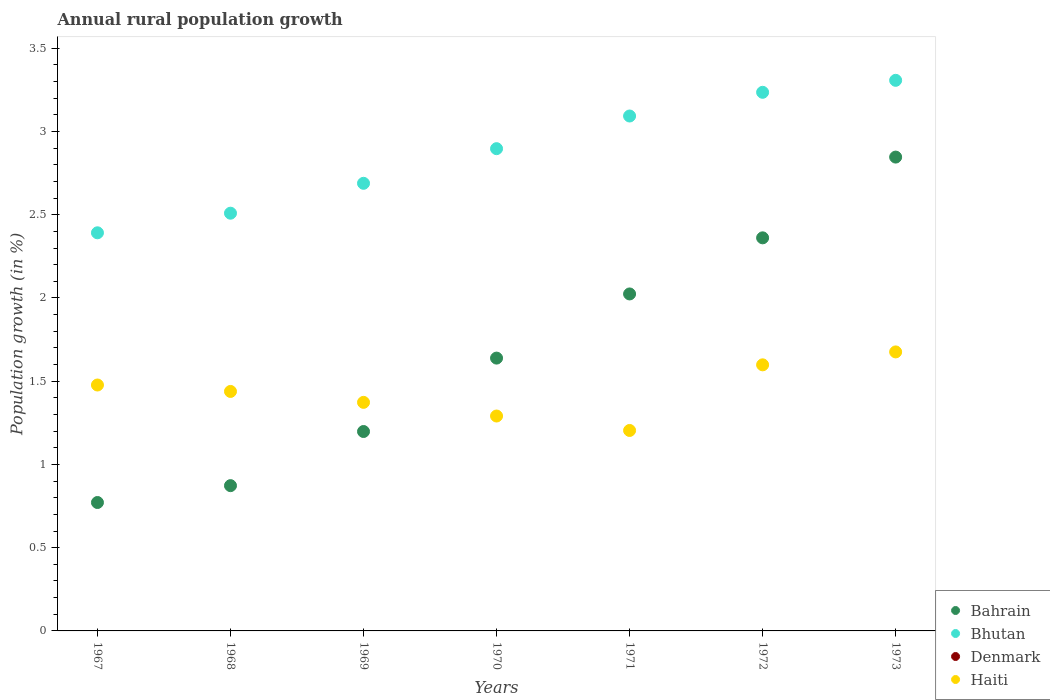How many different coloured dotlines are there?
Ensure brevity in your answer.  3. What is the percentage of rural population growth in Haiti in 1971?
Provide a succinct answer. 1.2. Across all years, what is the maximum percentage of rural population growth in Bhutan?
Your answer should be very brief. 3.31. Across all years, what is the minimum percentage of rural population growth in Denmark?
Provide a short and direct response. 0. In which year was the percentage of rural population growth in Bahrain maximum?
Offer a very short reply. 1973. What is the total percentage of rural population growth in Denmark in the graph?
Ensure brevity in your answer.  0. What is the difference between the percentage of rural population growth in Bhutan in 1969 and that in 1972?
Ensure brevity in your answer.  -0.55. What is the difference between the percentage of rural population growth in Bhutan in 1967 and the percentage of rural population growth in Bahrain in 1970?
Your response must be concise. 0.75. What is the average percentage of rural population growth in Bhutan per year?
Offer a very short reply. 2.87. In the year 1970, what is the difference between the percentage of rural population growth in Bahrain and percentage of rural population growth in Haiti?
Offer a terse response. 0.35. What is the ratio of the percentage of rural population growth in Haiti in 1970 to that in 1971?
Ensure brevity in your answer.  1.07. Is the percentage of rural population growth in Bahrain in 1969 less than that in 1970?
Offer a very short reply. Yes. Is the difference between the percentage of rural population growth in Bahrain in 1967 and 1973 greater than the difference between the percentage of rural population growth in Haiti in 1967 and 1973?
Keep it short and to the point. No. What is the difference between the highest and the second highest percentage of rural population growth in Bhutan?
Your response must be concise. 0.07. What is the difference between the highest and the lowest percentage of rural population growth in Haiti?
Keep it short and to the point. 0.47. In how many years, is the percentage of rural population growth in Denmark greater than the average percentage of rural population growth in Denmark taken over all years?
Provide a succinct answer. 0. Is it the case that in every year, the sum of the percentage of rural population growth in Denmark and percentage of rural population growth in Haiti  is greater than the percentage of rural population growth in Bhutan?
Offer a terse response. No. Is the percentage of rural population growth in Bhutan strictly greater than the percentage of rural population growth in Haiti over the years?
Your answer should be very brief. Yes. How many years are there in the graph?
Offer a very short reply. 7. What is the difference between two consecutive major ticks on the Y-axis?
Give a very brief answer. 0.5. Are the values on the major ticks of Y-axis written in scientific E-notation?
Offer a terse response. No. Where does the legend appear in the graph?
Provide a succinct answer. Bottom right. How many legend labels are there?
Ensure brevity in your answer.  4. What is the title of the graph?
Offer a terse response. Annual rural population growth. Does "Nepal" appear as one of the legend labels in the graph?
Ensure brevity in your answer.  No. What is the label or title of the X-axis?
Provide a short and direct response. Years. What is the label or title of the Y-axis?
Keep it short and to the point. Population growth (in %). What is the Population growth (in %) of Bahrain in 1967?
Provide a short and direct response. 0.77. What is the Population growth (in %) in Bhutan in 1967?
Offer a terse response. 2.39. What is the Population growth (in %) in Haiti in 1967?
Provide a succinct answer. 1.48. What is the Population growth (in %) in Bahrain in 1968?
Your answer should be very brief. 0.87. What is the Population growth (in %) of Bhutan in 1968?
Give a very brief answer. 2.51. What is the Population growth (in %) in Denmark in 1968?
Provide a succinct answer. 0. What is the Population growth (in %) of Haiti in 1968?
Offer a very short reply. 1.44. What is the Population growth (in %) in Bahrain in 1969?
Ensure brevity in your answer.  1.2. What is the Population growth (in %) of Bhutan in 1969?
Provide a short and direct response. 2.69. What is the Population growth (in %) in Denmark in 1969?
Provide a succinct answer. 0. What is the Population growth (in %) in Haiti in 1969?
Provide a succinct answer. 1.37. What is the Population growth (in %) of Bahrain in 1970?
Your answer should be compact. 1.64. What is the Population growth (in %) in Bhutan in 1970?
Give a very brief answer. 2.9. What is the Population growth (in %) of Haiti in 1970?
Your answer should be very brief. 1.29. What is the Population growth (in %) in Bahrain in 1971?
Make the answer very short. 2.02. What is the Population growth (in %) of Bhutan in 1971?
Keep it short and to the point. 3.09. What is the Population growth (in %) in Denmark in 1971?
Your response must be concise. 0. What is the Population growth (in %) of Haiti in 1971?
Your response must be concise. 1.2. What is the Population growth (in %) in Bahrain in 1972?
Offer a terse response. 2.36. What is the Population growth (in %) of Bhutan in 1972?
Your answer should be compact. 3.24. What is the Population growth (in %) in Haiti in 1972?
Your answer should be very brief. 1.6. What is the Population growth (in %) of Bahrain in 1973?
Make the answer very short. 2.85. What is the Population growth (in %) of Bhutan in 1973?
Ensure brevity in your answer.  3.31. What is the Population growth (in %) of Denmark in 1973?
Ensure brevity in your answer.  0. What is the Population growth (in %) of Haiti in 1973?
Keep it short and to the point. 1.68. Across all years, what is the maximum Population growth (in %) of Bahrain?
Your response must be concise. 2.85. Across all years, what is the maximum Population growth (in %) in Bhutan?
Keep it short and to the point. 3.31. Across all years, what is the maximum Population growth (in %) of Haiti?
Make the answer very short. 1.68. Across all years, what is the minimum Population growth (in %) in Bahrain?
Your answer should be very brief. 0.77. Across all years, what is the minimum Population growth (in %) in Bhutan?
Offer a terse response. 2.39. Across all years, what is the minimum Population growth (in %) of Haiti?
Offer a terse response. 1.2. What is the total Population growth (in %) in Bahrain in the graph?
Give a very brief answer. 11.71. What is the total Population growth (in %) in Bhutan in the graph?
Your answer should be compact. 20.12. What is the total Population growth (in %) of Haiti in the graph?
Provide a succinct answer. 10.06. What is the difference between the Population growth (in %) in Bahrain in 1967 and that in 1968?
Your response must be concise. -0.1. What is the difference between the Population growth (in %) in Bhutan in 1967 and that in 1968?
Your response must be concise. -0.12. What is the difference between the Population growth (in %) in Haiti in 1967 and that in 1968?
Provide a succinct answer. 0.04. What is the difference between the Population growth (in %) of Bahrain in 1967 and that in 1969?
Offer a terse response. -0.43. What is the difference between the Population growth (in %) of Bhutan in 1967 and that in 1969?
Keep it short and to the point. -0.3. What is the difference between the Population growth (in %) in Haiti in 1967 and that in 1969?
Ensure brevity in your answer.  0.1. What is the difference between the Population growth (in %) in Bahrain in 1967 and that in 1970?
Your answer should be very brief. -0.87. What is the difference between the Population growth (in %) of Bhutan in 1967 and that in 1970?
Ensure brevity in your answer.  -0.51. What is the difference between the Population growth (in %) in Haiti in 1967 and that in 1970?
Keep it short and to the point. 0.19. What is the difference between the Population growth (in %) of Bahrain in 1967 and that in 1971?
Make the answer very short. -1.25. What is the difference between the Population growth (in %) in Bhutan in 1967 and that in 1971?
Give a very brief answer. -0.7. What is the difference between the Population growth (in %) in Haiti in 1967 and that in 1971?
Keep it short and to the point. 0.27. What is the difference between the Population growth (in %) of Bahrain in 1967 and that in 1972?
Provide a short and direct response. -1.59. What is the difference between the Population growth (in %) of Bhutan in 1967 and that in 1972?
Provide a succinct answer. -0.84. What is the difference between the Population growth (in %) in Haiti in 1967 and that in 1972?
Keep it short and to the point. -0.12. What is the difference between the Population growth (in %) of Bahrain in 1967 and that in 1973?
Give a very brief answer. -2.07. What is the difference between the Population growth (in %) in Bhutan in 1967 and that in 1973?
Make the answer very short. -0.92. What is the difference between the Population growth (in %) in Haiti in 1967 and that in 1973?
Provide a short and direct response. -0.2. What is the difference between the Population growth (in %) in Bahrain in 1968 and that in 1969?
Provide a succinct answer. -0.33. What is the difference between the Population growth (in %) of Bhutan in 1968 and that in 1969?
Offer a terse response. -0.18. What is the difference between the Population growth (in %) of Haiti in 1968 and that in 1969?
Make the answer very short. 0.07. What is the difference between the Population growth (in %) in Bahrain in 1968 and that in 1970?
Provide a short and direct response. -0.77. What is the difference between the Population growth (in %) of Bhutan in 1968 and that in 1970?
Your response must be concise. -0.39. What is the difference between the Population growth (in %) in Haiti in 1968 and that in 1970?
Make the answer very short. 0.15. What is the difference between the Population growth (in %) of Bahrain in 1968 and that in 1971?
Offer a very short reply. -1.15. What is the difference between the Population growth (in %) in Bhutan in 1968 and that in 1971?
Your response must be concise. -0.58. What is the difference between the Population growth (in %) in Haiti in 1968 and that in 1971?
Provide a succinct answer. 0.23. What is the difference between the Population growth (in %) of Bahrain in 1968 and that in 1972?
Offer a terse response. -1.49. What is the difference between the Population growth (in %) in Bhutan in 1968 and that in 1972?
Your response must be concise. -0.73. What is the difference between the Population growth (in %) in Haiti in 1968 and that in 1972?
Provide a succinct answer. -0.16. What is the difference between the Population growth (in %) of Bahrain in 1968 and that in 1973?
Keep it short and to the point. -1.97. What is the difference between the Population growth (in %) of Bhutan in 1968 and that in 1973?
Your response must be concise. -0.8. What is the difference between the Population growth (in %) in Haiti in 1968 and that in 1973?
Make the answer very short. -0.24. What is the difference between the Population growth (in %) in Bahrain in 1969 and that in 1970?
Your response must be concise. -0.44. What is the difference between the Population growth (in %) of Bhutan in 1969 and that in 1970?
Your response must be concise. -0.21. What is the difference between the Population growth (in %) in Haiti in 1969 and that in 1970?
Give a very brief answer. 0.08. What is the difference between the Population growth (in %) of Bahrain in 1969 and that in 1971?
Keep it short and to the point. -0.83. What is the difference between the Population growth (in %) in Bhutan in 1969 and that in 1971?
Make the answer very short. -0.4. What is the difference between the Population growth (in %) of Haiti in 1969 and that in 1971?
Make the answer very short. 0.17. What is the difference between the Population growth (in %) of Bahrain in 1969 and that in 1972?
Ensure brevity in your answer.  -1.16. What is the difference between the Population growth (in %) of Bhutan in 1969 and that in 1972?
Give a very brief answer. -0.55. What is the difference between the Population growth (in %) of Haiti in 1969 and that in 1972?
Your answer should be compact. -0.23. What is the difference between the Population growth (in %) in Bahrain in 1969 and that in 1973?
Offer a very short reply. -1.65. What is the difference between the Population growth (in %) in Bhutan in 1969 and that in 1973?
Ensure brevity in your answer.  -0.62. What is the difference between the Population growth (in %) of Haiti in 1969 and that in 1973?
Ensure brevity in your answer.  -0.3. What is the difference between the Population growth (in %) in Bahrain in 1970 and that in 1971?
Provide a succinct answer. -0.39. What is the difference between the Population growth (in %) of Bhutan in 1970 and that in 1971?
Your answer should be very brief. -0.2. What is the difference between the Population growth (in %) of Haiti in 1970 and that in 1971?
Offer a very short reply. 0.09. What is the difference between the Population growth (in %) in Bahrain in 1970 and that in 1972?
Your answer should be very brief. -0.72. What is the difference between the Population growth (in %) of Bhutan in 1970 and that in 1972?
Keep it short and to the point. -0.34. What is the difference between the Population growth (in %) of Haiti in 1970 and that in 1972?
Make the answer very short. -0.31. What is the difference between the Population growth (in %) in Bahrain in 1970 and that in 1973?
Give a very brief answer. -1.21. What is the difference between the Population growth (in %) of Bhutan in 1970 and that in 1973?
Your response must be concise. -0.41. What is the difference between the Population growth (in %) in Haiti in 1970 and that in 1973?
Offer a terse response. -0.39. What is the difference between the Population growth (in %) of Bahrain in 1971 and that in 1972?
Offer a very short reply. -0.34. What is the difference between the Population growth (in %) of Bhutan in 1971 and that in 1972?
Make the answer very short. -0.14. What is the difference between the Population growth (in %) in Haiti in 1971 and that in 1972?
Keep it short and to the point. -0.39. What is the difference between the Population growth (in %) in Bahrain in 1971 and that in 1973?
Provide a short and direct response. -0.82. What is the difference between the Population growth (in %) of Bhutan in 1971 and that in 1973?
Your answer should be compact. -0.21. What is the difference between the Population growth (in %) of Haiti in 1971 and that in 1973?
Provide a succinct answer. -0.47. What is the difference between the Population growth (in %) of Bahrain in 1972 and that in 1973?
Ensure brevity in your answer.  -0.49. What is the difference between the Population growth (in %) in Bhutan in 1972 and that in 1973?
Provide a succinct answer. -0.07. What is the difference between the Population growth (in %) in Haiti in 1972 and that in 1973?
Your answer should be very brief. -0.08. What is the difference between the Population growth (in %) of Bahrain in 1967 and the Population growth (in %) of Bhutan in 1968?
Provide a short and direct response. -1.74. What is the difference between the Population growth (in %) in Bahrain in 1967 and the Population growth (in %) in Haiti in 1968?
Ensure brevity in your answer.  -0.67. What is the difference between the Population growth (in %) of Bhutan in 1967 and the Population growth (in %) of Haiti in 1968?
Your response must be concise. 0.95. What is the difference between the Population growth (in %) in Bahrain in 1967 and the Population growth (in %) in Bhutan in 1969?
Provide a short and direct response. -1.92. What is the difference between the Population growth (in %) in Bahrain in 1967 and the Population growth (in %) in Haiti in 1969?
Ensure brevity in your answer.  -0.6. What is the difference between the Population growth (in %) in Bhutan in 1967 and the Population growth (in %) in Haiti in 1969?
Ensure brevity in your answer.  1.02. What is the difference between the Population growth (in %) of Bahrain in 1967 and the Population growth (in %) of Bhutan in 1970?
Provide a succinct answer. -2.13. What is the difference between the Population growth (in %) in Bahrain in 1967 and the Population growth (in %) in Haiti in 1970?
Ensure brevity in your answer.  -0.52. What is the difference between the Population growth (in %) of Bhutan in 1967 and the Population growth (in %) of Haiti in 1970?
Ensure brevity in your answer.  1.1. What is the difference between the Population growth (in %) of Bahrain in 1967 and the Population growth (in %) of Bhutan in 1971?
Your response must be concise. -2.32. What is the difference between the Population growth (in %) of Bahrain in 1967 and the Population growth (in %) of Haiti in 1971?
Provide a short and direct response. -0.43. What is the difference between the Population growth (in %) in Bhutan in 1967 and the Population growth (in %) in Haiti in 1971?
Keep it short and to the point. 1.19. What is the difference between the Population growth (in %) of Bahrain in 1967 and the Population growth (in %) of Bhutan in 1972?
Your answer should be compact. -2.46. What is the difference between the Population growth (in %) in Bahrain in 1967 and the Population growth (in %) in Haiti in 1972?
Keep it short and to the point. -0.83. What is the difference between the Population growth (in %) in Bhutan in 1967 and the Population growth (in %) in Haiti in 1972?
Make the answer very short. 0.79. What is the difference between the Population growth (in %) of Bahrain in 1967 and the Population growth (in %) of Bhutan in 1973?
Give a very brief answer. -2.54. What is the difference between the Population growth (in %) of Bahrain in 1967 and the Population growth (in %) of Haiti in 1973?
Your response must be concise. -0.9. What is the difference between the Population growth (in %) in Bhutan in 1967 and the Population growth (in %) in Haiti in 1973?
Provide a succinct answer. 0.72. What is the difference between the Population growth (in %) in Bahrain in 1968 and the Population growth (in %) in Bhutan in 1969?
Your answer should be very brief. -1.82. What is the difference between the Population growth (in %) of Bahrain in 1968 and the Population growth (in %) of Haiti in 1969?
Your answer should be very brief. -0.5. What is the difference between the Population growth (in %) in Bhutan in 1968 and the Population growth (in %) in Haiti in 1969?
Make the answer very short. 1.14. What is the difference between the Population growth (in %) in Bahrain in 1968 and the Population growth (in %) in Bhutan in 1970?
Offer a very short reply. -2.02. What is the difference between the Population growth (in %) in Bahrain in 1968 and the Population growth (in %) in Haiti in 1970?
Your response must be concise. -0.42. What is the difference between the Population growth (in %) of Bhutan in 1968 and the Population growth (in %) of Haiti in 1970?
Offer a very short reply. 1.22. What is the difference between the Population growth (in %) of Bahrain in 1968 and the Population growth (in %) of Bhutan in 1971?
Keep it short and to the point. -2.22. What is the difference between the Population growth (in %) of Bahrain in 1968 and the Population growth (in %) of Haiti in 1971?
Your response must be concise. -0.33. What is the difference between the Population growth (in %) of Bhutan in 1968 and the Population growth (in %) of Haiti in 1971?
Make the answer very short. 1.31. What is the difference between the Population growth (in %) in Bahrain in 1968 and the Population growth (in %) in Bhutan in 1972?
Your response must be concise. -2.36. What is the difference between the Population growth (in %) in Bahrain in 1968 and the Population growth (in %) in Haiti in 1972?
Give a very brief answer. -0.73. What is the difference between the Population growth (in %) of Bhutan in 1968 and the Population growth (in %) of Haiti in 1972?
Offer a very short reply. 0.91. What is the difference between the Population growth (in %) in Bahrain in 1968 and the Population growth (in %) in Bhutan in 1973?
Offer a very short reply. -2.43. What is the difference between the Population growth (in %) in Bahrain in 1968 and the Population growth (in %) in Haiti in 1973?
Provide a succinct answer. -0.8. What is the difference between the Population growth (in %) of Bhutan in 1968 and the Population growth (in %) of Haiti in 1973?
Make the answer very short. 0.83. What is the difference between the Population growth (in %) in Bahrain in 1969 and the Population growth (in %) in Bhutan in 1970?
Offer a terse response. -1.7. What is the difference between the Population growth (in %) of Bahrain in 1969 and the Population growth (in %) of Haiti in 1970?
Ensure brevity in your answer.  -0.09. What is the difference between the Population growth (in %) of Bhutan in 1969 and the Population growth (in %) of Haiti in 1970?
Your answer should be compact. 1.4. What is the difference between the Population growth (in %) in Bahrain in 1969 and the Population growth (in %) in Bhutan in 1971?
Your answer should be compact. -1.9. What is the difference between the Population growth (in %) in Bahrain in 1969 and the Population growth (in %) in Haiti in 1971?
Provide a short and direct response. -0.01. What is the difference between the Population growth (in %) in Bhutan in 1969 and the Population growth (in %) in Haiti in 1971?
Offer a very short reply. 1.48. What is the difference between the Population growth (in %) of Bahrain in 1969 and the Population growth (in %) of Bhutan in 1972?
Your answer should be very brief. -2.04. What is the difference between the Population growth (in %) in Bahrain in 1969 and the Population growth (in %) in Haiti in 1972?
Your response must be concise. -0.4. What is the difference between the Population growth (in %) in Bhutan in 1969 and the Population growth (in %) in Haiti in 1972?
Offer a terse response. 1.09. What is the difference between the Population growth (in %) of Bahrain in 1969 and the Population growth (in %) of Bhutan in 1973?
Your answer should be very brief. -2.11. What is the difference between the Population growth (in %) in Bahrain in 1969 and the Population growth (in %) in Haiti in 1973?
Your response must be concise. -0.48. What is the difference between the Population growth (in %) of Bhutan in 1969 and the Population growth (in %) of Haiti in 1973?
Your response must be concise. 1.01. What is the difference between the Population growth (in %) in Bahrain in 1970 and the Population growth (in %) in Bhutan in 1971?
Offer a terse response. -1.45. What is the difference between the Population growth (in %) of Bahrain in 1970 and the Population growth (in %) of Haiti in 1971?
Ensure brevity in your answer.  0.43. What is the difference between the Population growth (in %) in Bhutan in 1970 and the Population growth (in %) in Haiti in 1971?
Provide a succinct answer. 1.69. What is the difference between the Population growth (in %) in Bahrain in 1970 and the Population growth (in %) in Bhutan in 1972?
Ensure brevity in your answer.  -1.6. What is the difference between the Population growth (in %) in Bahrain in 1970 and the Population growth (in %) in Haiti in 1972?
Ensure brevity in your answer.  0.04. What is the difference between the Population growth (in %) in Bhutan in 1970 and the Population growth (in %) in Haiti in 1972?
Offer a very short reply. 1.3. What is the difference between the Population growth (in %) of Bahrain in 1970 and the Population growth (in %) of Bhutan in 1973?
Your answer should be very brief. -1.67. What is the difference between the Population growth (in %) of Bahrain in 1970 and the Population growth (in %) of Haiti in 1973?
Provide a short and direct response. -0.04. What is the difference between the Population growth (in %) in Bhutan in 1970 and the Population growth (in %) in Haiti in 1973?
Your answer should be compact. 1.22. What is the difference between the Population growth (in %) in Bahrain in 1971 and the Population growth (in %) in Bhutan in 1972?
Offer a very short reply. -1.21. What is the difference between the Population growth (in %) of Bahrain in 1971 and the Population growth (in %) of Haiti in 1972?
Your answer should be compact. 0.43. What is the difference between the Population growth (in %) in Bhutan in 1971 and the Population growth (in %) in Haiti in 1972?
Provide a succinct answer. 1.49. What is the difference between the Population growth (in %) of Bahrain in 1971 and the Population growth (in %) of Bhutan in 1973?
Your response must be concise. -1.28. What is the difference between the Population growth (in %) of Bahrain in 1971 and the Population growth (in %) of Haiti in 1973?
Offer a terse response. 0.35. What is the difference between the Population growth (in %) in Bhutan in 1971 and the Population growth (in %) in Haiti in 1973?
Your response must be concise. 1.42. What is the difference between the Population growth (in %) of Bahrain in 1972 and the Population growth (in %) of Bhutan in 1973?
Ensure brevity in your answer.  -0.95. What is the difference between the Population growth (in %) in Bahrain in 1972 and the Population growth (in %) in Haiti in 1973?
Provide a succinct answer. 0.69. What is the difference between the Population growth (in %) in Bhutan in 1972 and the Population growth (in %) in Haiti in 1973?
Keep it short and to the point. 1.56. What is the average Population growth (in %) in Bahrain per year?
Make the answer very short. 1.67. What is the average Population growth (in %) in Bhutan per year?
Provide a succinct answer. 2.87. What is the average Population growth (in %) in Haiti per year?
Keep it short and to the point. 1.44. In the year 1967, what is the difference between the Population growth (in %) in Bahrain and Population growth (in %) in Bhutan?
Provide a short and direct response. -1.62. In the year 1967, what is the difference between the Population growth (in %) of Bahrain and Population growth (in %) of Haiti?
Make the answer very short. -0.71. In the year 1967, what is the difference between the Population growth (in %) in Bhutan and Population growth (in %) in Haiti?
Your answer should be very brief. 0.91. In the year 1968, what is the difference between the Population growth (in %) of Bahrain and Population growth (in %) of Bhutan?
Your response must be concise. -1.64. In the year 1968, what is the difference between the Population growth (in %) of Bahrain and Population growth (in %) of Haiti?
Give a very brief answer. -0.57. In the year 1968, what is the difference between the Population growth (in %) of Bhutan and Population growth (in %) of Haiti?
Provide a short and direct response. 1.07. In the year 1969, what is the difference between the Population growth (in %) of Bahrain and Population growth (in %) of Bhutan?
Offer a very short reply. -1.49. In the year 1969, what is the difference between the Population growth (in %) of Bahrain and Population growth (in %) of Haiti?
Keep it short and to the point. -0.18. In the year 1969, what is the difference between the Population growth (in %) in Bhutan and Population growth (in %) in Haiti?
Your answer should be compact. 1.32. In the year 1970, what is the difference between the Population growth (in %) in Bahrain and Population growth (in %) in Bhutan?
Offer a very short reply. -1.26. In the year 1970, what is the difference between the Population growth (in %) of Bahrain and Population growth (in %) of Haiti?
Provide a short and direct response. 0.35. In the year 1970, what is the difference between the Population growth (in %) in Bhutan and Population growth (in %) in Haiti?
Give a very brief answer. 1.61. In the year 1971, what is the difference between the Population growth (in %) in Bahrain and Population growth (in %) in Bhutan?
Offer a terse response. -1.07. In the year 1971, what is the difference between the Population growth (in %) in Bahrain and Population growth (in %) in Haiti?
Your answer should be compact. 0.82. In the year 1971, what is the difference between the Population growth (in %) of Bhutan and Population growth (in %) of Haiti?
Offer a terse response. 1.89. In the year 1972, what is the difference between the Population growth (in %) of Bahrain and Population growth (in %) of Bhutan?
Make the answer very short. -0.87. In the year 1972, what is the difference between the Population growth (in %) in Bahrain and Population growth (in %) in Haiti?
Give a very brief answer. 0.76. In the year 1972, what is the difference between the Population growth (in %) of Bhutan and Population growth (in %) of Haiti?
Provide a short and direct response. 1.64. In the year 1973, what is the difference between the Population growth (in %) in Bahrain and Population growth (in %) in Bhutan?
Offer a terse response. -0.46. In the year 1973, what is the difference between the Population growth (in %) in Bahrain and Population growth (in %) in Haiti?
Ensure brevity in your answer.  1.17. In the year 1973, what is the difference between the Population growth (in %) in Bhutan and Population growth (in %) in Haiti?
Provide a short and direct response. 1.63. What is the ratio of the Population growth (in %) of Bahrain in 1967 to that in 1968?
Your answer should be very brief. 0.88. What is the ratio of the Population growth (in %) of Bhutan in 1967 to that in 1968?
Provide a short and direct response. 0.95. What is the ratio of the Population growth (in %) of Haiti in 1967 to that in 1968?
Keep it short and to the point. 1.03. What is the ratio of the Population growth (in %) in Bahrain in 1967 to that in 1969?
Keep it short and to the point. 0.64. What is the ratio of the Population growth (in %) in Bhutan in 1967 to that in 1969?
Make the answer very short. 0.89. What is the ratio of the Population growth (in %) of Haiti in 1967 to that in 1969?
Your answer should be very brief. 1.08. What is the ratio of the Population growth (in %) in Bahrain in 1967 to that in 1970?
Your answer should be very brief. 0.47. What is the ratio of the Population growth (in %) of Bhutan in 1967 to that in 1970?
Make the answer very short. 0.83. What is the ratio of the Population growth (in %) in Haiti in 1967 to that in 1970?
Offer a very short reply. 1.14. What is the ratio of the Population growth (in %) in Bahrain in 1967 to that in 1971?
Your answer should be compact. 0.38. What is the ratio of the Population growth (in %) in Bhutan in 1967 to that in 1971?
Offer a terse response. 0.77. What is the ratio of the Population growth (in %) in Haiti in 1967 to that in 1971?
Offer a very short reply. 1.23. What is the ratio of the Population growth (in %) of Bahrain in 1967 to that in 1972?
Your answer should be very brief. 0.33. What is the ratio of the Population growth (in %) in Bhutan in 1967 to that in 1972?
Provide a succinct answer. 0.74. What is the ratio of the Population growth (in %) in Haiti in 1967 to that in 1972?
Offer a terse response. 0.92. What is the ratio of the Population growth (in %) of Bahrain in 1967 to that in 1973?
Your answer should be compact. 0.27. What is the ratio of the Population growth (in %) in Bhutan in 1967 to that in 1973?
Make the answer very short. 0.72. What is the ratio of the Population growth (in %) of Haiti in 1967 to that in 1973?
Your response must be concise. 0.88. What is the ratio of the Population growth (in %) of Bahrain in 1968 to that in 1969?
Ensure brevity in your answer.  0.73. What is the ratio of the Population growth (in %) in Bhutan in 1968 to that in 1969?
Provide a succinct answer. 0.93. What is the ratio of the Population growth (in %) of Haiti in 1968 to that in 1969?
Offer a very short reply. 1.05. What is the ratio of the Population growth (in %) in Bahrain in 1968 to that in 1970?
Make the answer very short. 0.53. What is the ratio of the Population growth (in %) of Bhutan in 1968 to that in 1970?
Ensure brevity in your answer.  0.87. What is the ratio of the Population growth (in %) in Haiti in 1968 to that in 1970?
Ensure brevity in your answer.  1.11. What is the ratio of the Population growth (in %) in Bahrain in 1968 to that in 1971?
Keep it short and to the point. 0.43. What is the ratio of the Population growth (in %) of Bhutan in 1968 to that in 1971?
Ensure brevity in your answer.  0.81. What is the ratio of the Population growth (in %) of Haiti in 1968 to that in 1971?
Offer a very short reply. 1.19. What is the ratio of the Population growth (in %) of Bahrain in 1968 to that in 1972?
Ensure brevity in your answer.  0.37. What is the ratio of the Population growth (in %) of Bhutan in 1968 to that in 1972?
Your answer should be compact. 0.78. What is the ratio of the Population growth (in %) in Bahrain in 1968 to that in 1973?
Provide a succinct answer. 0.31. What is the ratio of the Population growth (in %) of Bhutan in 1968 to that in 1973?
Give a very brief answer. 0.76. What is the ratio of the Population growth (in %) in Haiti in 1968 to that in 1973?
Your response must be concise. 0.86. What is the ratio of the Population growth (in %) in Bahrain in 1969 to that in 1970?
Provide a succinct answer. 0.73. What is the ratio of the Population growth (in %) of Bhutan in 1969 to that in 1970?
Make the answer very short. 0.93. What is the ratio of the Population growth (in %) in Haiti in 1969 to that in 1970?
Ensure brevity in your answer.  1.06. What is the ratio of the Population growth (in %) in Bahrain in 1969 to that in 1971?
Your response must be concise. 0.59. What is the ratio of the Population growth (in %) in Bhutan in 1969 to that in 1971?
Your answer should be compact. 0.87. What is the ratio of the Population growth (in %) of Haiti in 1969 to that in 1971?
Give a very brief answer. 1.14. What is the ratio of the Population growth (in %) in Bahrain in 1969 to that in 1972?
Keep it short and to the point. 0.51. What is the ratio of the Population growth (in %) in Bhutan in 1969 to that in 1972?
Keep it short and to the point. 0.83. What is the ratio of the Population growth (in %) of Haiti in 1969 to that in 1972?
Offer a very short reply. 0.86. What is the ratio of the Population growth (in %) in Bahrain in 1969 to that in 1973?
Offer a very short reply. 0.42. What is the ratio of the Population growth (in %) of Bhutan in 1969 to that in 1973?
Provide a short and direct response. 0.81. What is the ratio of the Population growth (in %) of Haiti in 1969 to that in 1973?
Your answer should be very brief. 0.82. What is the ratio of the Population growth (in %) of Bahrain in 1970 to that in 1971?
Provide a short and direct response. 0.81. What is the ratio of the Population growth (in %) of Bhutan in 1970 to that in 1971?
Make the answer very short. 0.94. What is the ratio of the Population growth (in %) of Haiti in 1970 to that in 1971?
Your answer should be very brief. 1.07. What is the ratio of the Population growth (in %) in Bahrain in 1970 to that in 1972?
Your response must be concise. 0.69. What is the ratio of the Population growth (in %) in Bhutan in 1970 to that in 1972?
Offer a very short reply. 0.9. What is the ratio of the Population growth (in %) in Haiti in 1970 to that in 1972?
Ensure brevity in your answer.  0.81. What is the ratio of the Population growth (in %) in Bahrain in 1970 to that in 1973?
Keep it short and to the point. 0.58. What is the ratio of the Population growth (in %) in Bhutan in 1970 to that in 1973?
Provide a short and direct response. 0.88. What is the ratio of the Population growth (in %) of Haiti in 1970 to that in 1973?
Give a very brief answer. 0.77. What is the ratio of the Population growth (in %) of Bahrain in 1971 to that in 1972?
Give a very brief answer. 0.86. What is the ratio of the Population growth (in %) of Bhutan in 1971 to that in 1972?
Provide a succinct answer. 0.96. What is the ratio of the Population growth (in %) in Haiti in 1971 to that in 1972?
Your answer should be very brief. 0.75. What is the ratio of the Population growth (in %) in Bahrain in 1971 to that in 1973?
Your answer should be compact. 0.71. What is the ratio of the Population growth (in %) in Bhutan in 1971 to that in 1973?
Make the answer very short. 0.94. What is the ratio of the Population growth (in %) of Haiti in 1971 to that in 1973?
Offer a terse response. 0.72. What is the ratio of the Population growth (in %) in Bahrain in 1972 to that in 1973?
Keep it short and to the point. 0.83. What is the ratio of the Population growth (in %) of Bhutan in 1972 to that in 1973?
Your answer should be compact. 0.98. What is the ratio of the Population growth (in %) in Haiti in 1972 to that in 1973?
Ensure brevity in your answer.  0.95. What is the difference between the highest and the second highest Population growth (in %) of Bahrain?
Make the answer very short. 0.49. What is the difference between the highest and the second highest Population growth (in %) of Bhutan?
Keep it short and to the point. 0.07. What is the difference between the highest and the second highest Population growth (in %) in Haiti?
Ensure brevity in your answer.  0.08. What is the difference between the highest and the lowest Population growth (in %) of Bahrain?
Your answer should be compact. 2.07. What is the difference between the highest and the lowest Population growth (in %) in Bhutan?
Make the answer very short. 0.92. What is the difference between the highest and the lowest Population growth (in %) in Haiti?
Give a very brief answer. 0.47. 